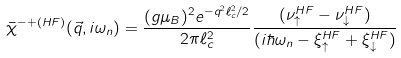<formula> <loc_0><loc_0><loc_500><loc_500>\bar { \chi } ^ { - + ( H F ) } ( \vec { q } , i \omega _ { n } ) = \frac { ( g \mu _ { B } ) ^ { 2 } e ^ { - q ^ { 2 } \ell _ { c } ^ { 2 } / 2 } } { 2 \pi \ell _ { c } ^ { 2 } } \frac { ( \nu _ { \uparrow } ^ { H F } - \nu _ { \downarrow } ^ { H F } ) } { ( i \hbar { \omega } _ { n } - \xi _ { \uparrow } ^ { H F } + \xi _ { \downarrow } ^ { H F } ) }</formula> 